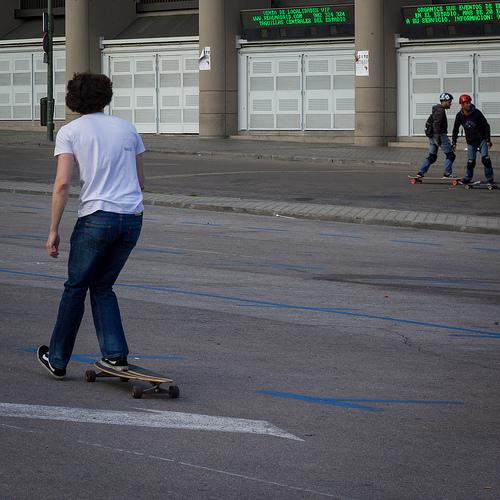Summarize the image's main scenario involving the man and the skateboard. The image depicts a man wearing casual attire and skateboarding on a black and tan skateboard with black wheels in the street. Talk about the details on the street that are visible in the image. In the street, there are blue lines, a white arrow, and a man skateboarding. Describe the skateboard and its wheels in the image. The skateboard is black and tan with black wheels, being ridden by a man in the street. List the main colors and elements of the image, including the skateboarder and street. Blue jeans, white shirt, black and white shoes, black and tan skateboard, black wheels, blue lines, and white arrow in the street. Give a brief description of the skateboarder's attire and his actions in the image. The skateboarder is wearing blue jeans, a white shirt, and black and white shoes while riding a skateboard in the street. Provide a brief description of the scene involving the skateboarder. A man skateboarding in the street, wearing blue jeans, black and white shoes, and a white shirt. Write a short sentence about the man's footwear and what he is doing in the image. The man, wearing black and white shoes, is skateboarding in the street. Mention the color and type of shoes the man is wearing and the brand they belong to. The man is wearing black and white Vans brand shoes while skateboarding. Write a statement about the type of skateboard and its wheels present in the image. A black and tan skateboard with black wheels is seen on the street. Comment on the clothing and accessories worn by the skateboarder in the image. The skateboarder is dressed in blue jeans, a white shirt, and black and white shoes. 